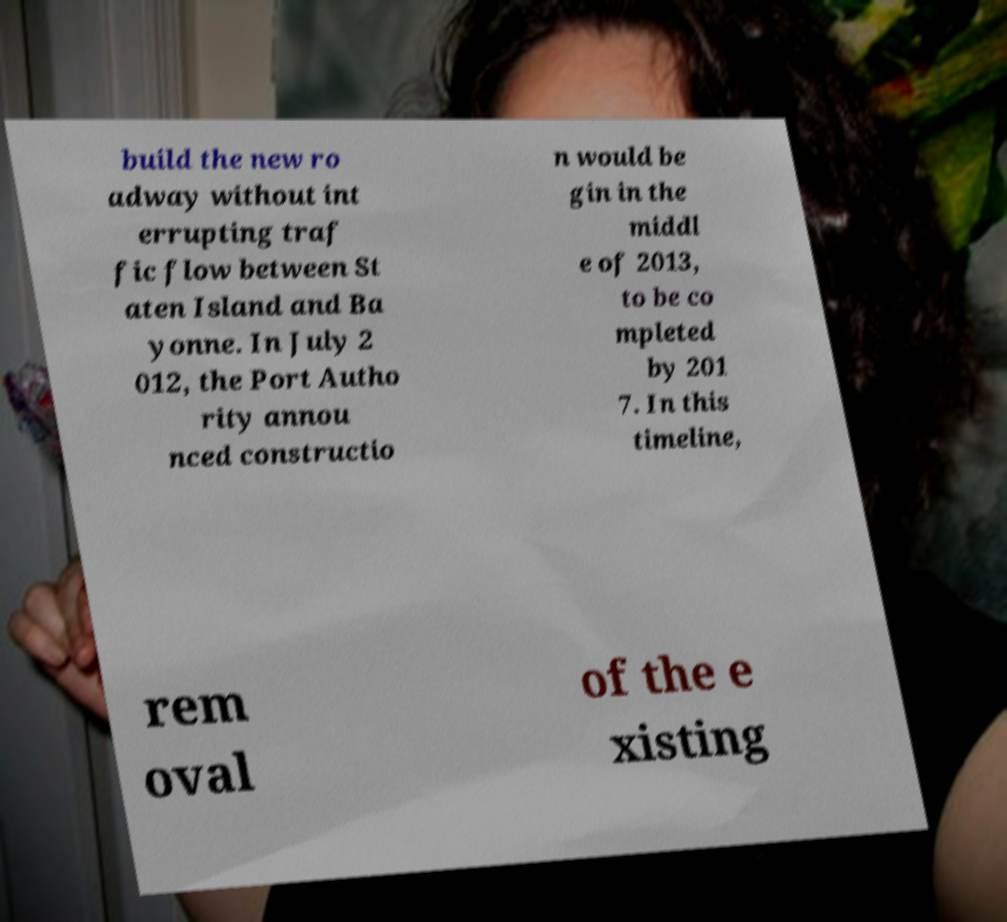There's text embedded in this image that I need extracted. Can you transcribe it verbatim? build the new ro adway without int errupting traf fic flow between St aten Island and Ba yonne. In July 2 012, the Port Autho rity annou nced constructio n would be gin in the middl e of 2013, to be co mpleted by 201 7. In this timeline, rem oval of the e xisting 